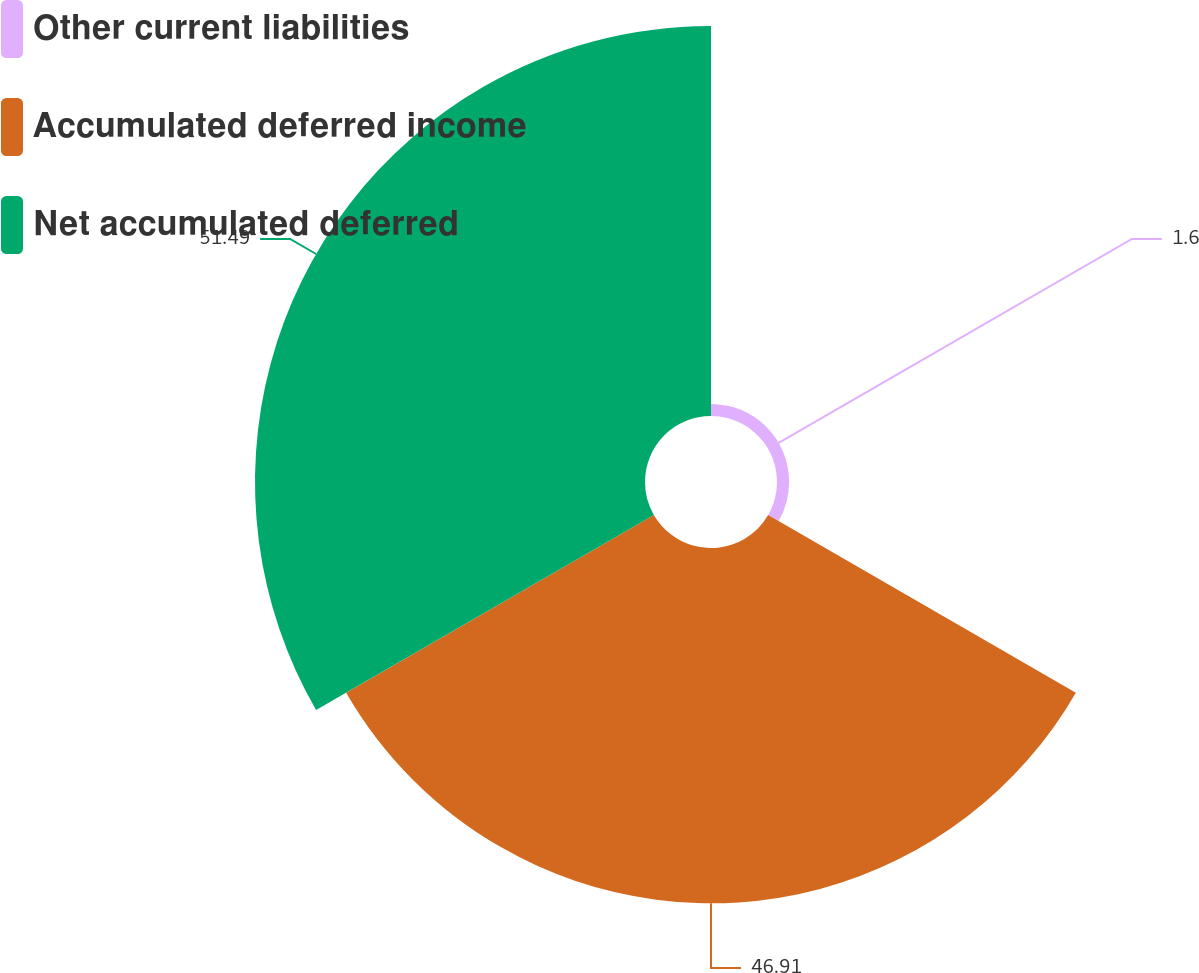Convert chart to OTSL. <chart><loc_0><loc_0><loc_500><loc_500><pie_chart><fcel>Other current liabilities<fcel>Accumulated deferred income<fcel>Net accumulated deferred<nl><fcel>1.6%<fcel>46.91%<fcel>51.49%<nl></chart> 